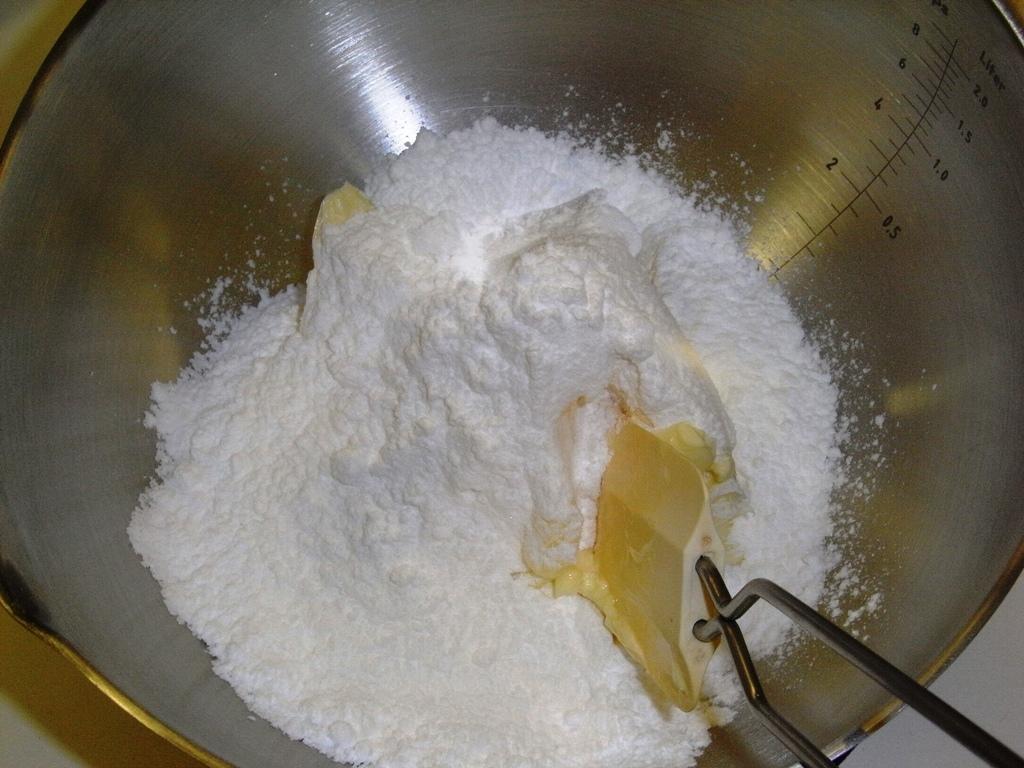Can you describe this image briefly? In this image, we can see flour in a steel container and we can see a whisk in the bowl. 